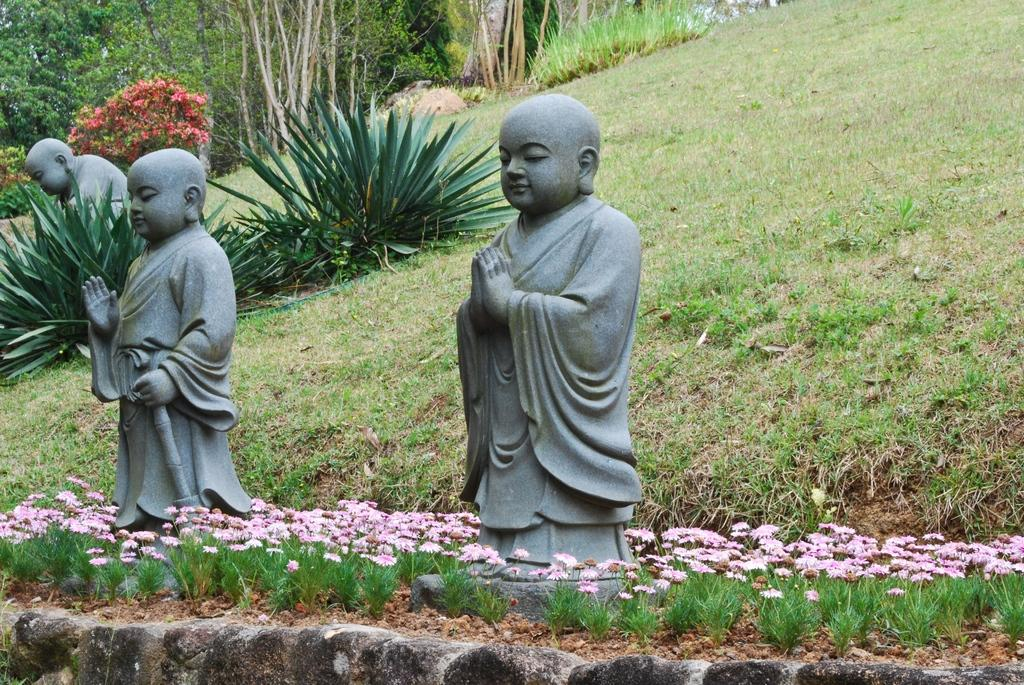What type of objects can be seen in the image? There are statues in the image. What type of vegetation is visible in the image? There is grass, flowers, trees, and plants visible in the image. What type of arm can be seen holding a rat in the image? There is no arm or rat present in the image. Is there any water visible in the image? There is no water visible in the image. 